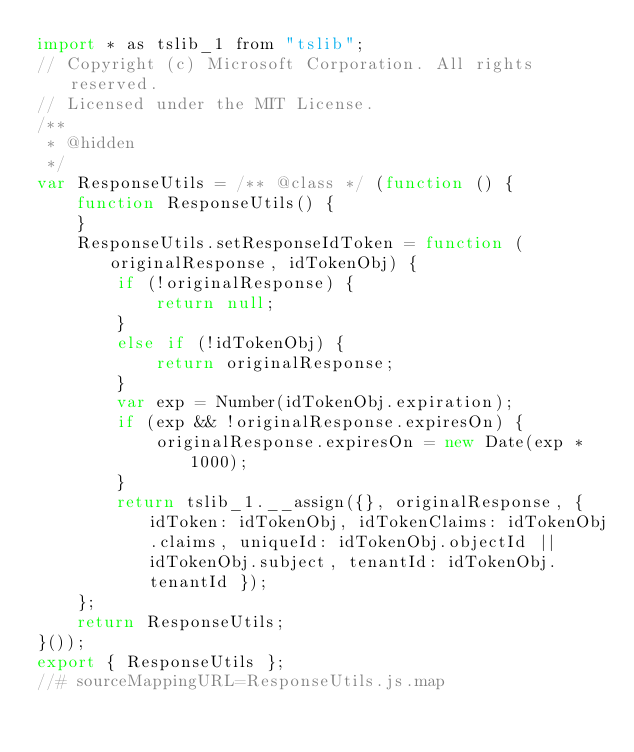<code> <loc_0><loc_0><loc_500><loc_500><_JavaScript_>import * as tslib_1 from "tslib";
// Copyright (c) Microsoft Corporation. All rights reserved.
// Licensed under the MIT License.
/**
 * @hidden
 */
var ResponseUtils = /** @class */ (function () {
    function ResponseUtils() {
    }
    ResponseUtils.setResponseIdToken = function (originalResponse, idTokenObj) {
        if (!originalResponse) {
            return null;
        }
        else if (!idTokenObj) {
            return originalResponse;
        }
        var exp = Number(idTokenObj.expiration);
        if (exp && !originalResponse.expiresOn) {
            originalResponse.expiresOn = new Date(exp * 1000);
        }
        return tslib_1.__assign({}, originalResponse, { idToken: idTokenObj, idTokenClaims: idTokenObj.claims, uniqueId: idTokenObj.objectId || idTokenObj.subject, tenantId: idTokenObj.tenantId });
    };
    return ResponseUtils;
}());
export { ResponseUtils };
//# sourceMappingURL=ResponseUtils.js.map</code> 